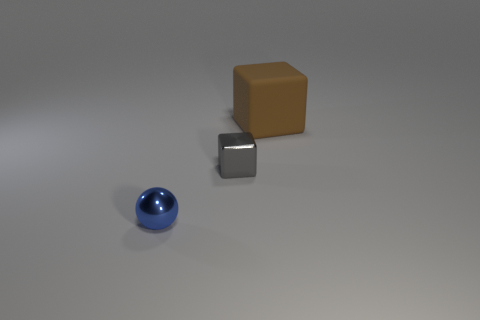Subtract all brown blocks. How many blocks are left? 1 Subtract 1 blocks. How many blocks are left? 1 Subtract all balls. How many objects are left? 2 Add 3 small blue metallic cylinders. How many objects exist? 6 Subtract all gray blocks. Subtract all yellow cylinders. How many blocks are left? 1 Subtract all cyan balls. How many gray cubes are left? 1 Subtract all brown rubber blocks. Subtract all tiny shiny objects. How many objects are left? 0 Add 2 small metallic spheres. How many small metallic spheres are left? 3 Add 2 big red matte objects. How many big red matte objects exist? 2 Subtract 1 blue spheres. How many objects are left? 2 